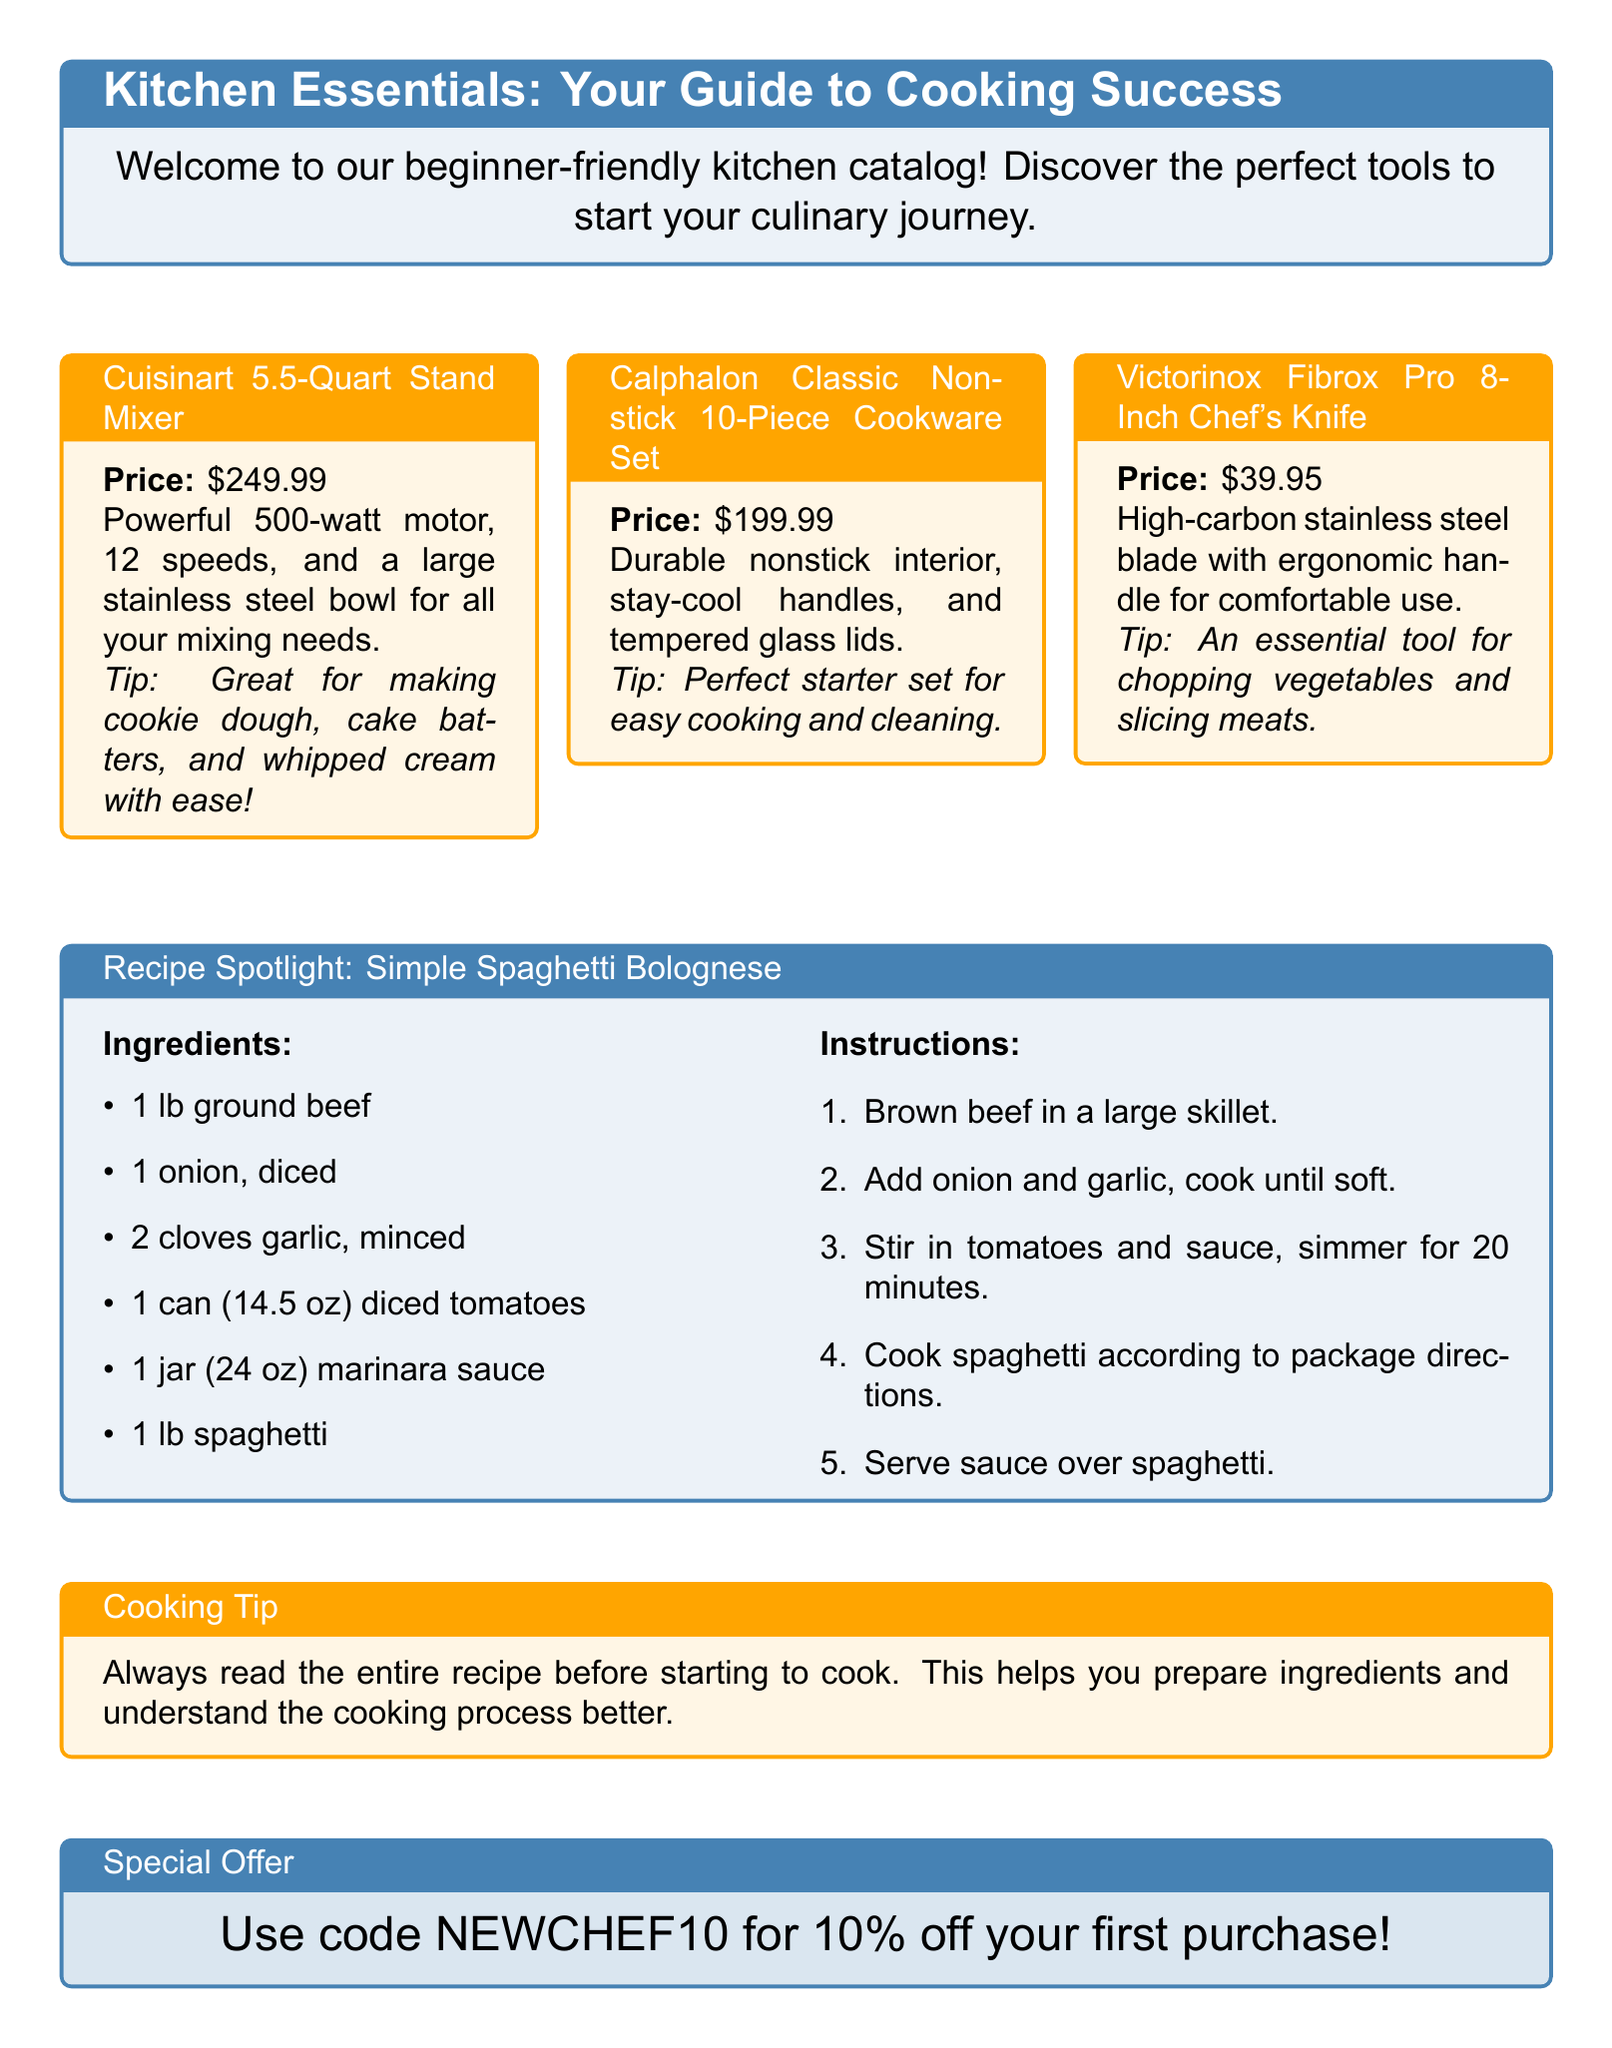what is the price of the Cuisinart Stand Mixer? The price of the Cuisinart 5.5-Quart Stand Mixer is listed in the document.
Answer: $249.99 how many pieces are in the Calphalon Cookware Set? The Calphalon Classic Nonstick Cookware Set details how many pieces it contains.
Answer: 10-Piece what type of blade does the Victorinox Chef's Knife have? The Victorinox Fibrox Pro 8-Inch Chef's Knife description states the type of blade material.
Answer: High-carbon stainless steel what is the first ingredient in the spaghetti bolognese recipe? The recipe spotlight lists the ingredients in order, and the first one is noted in the list.
Answer: Ground beef how long should you simmer the sauce in the spaghetti bolognese recipe? The instructions in the recipe specify the duration for this particular step.
Answer: 20 minutes what is a cooking tip mentioned in the document? The cooking tip provided suggests an important preparation step for cooking.
Answer: Read the entire recipe what discount code is offered in the special offer? The special offer section includes a code for first-time buyers.
Answer: NEWCHEF10 what is the purpose of the kitchen catalog? The introduction of the document explains the catalog's purpose for new cooks.
Answer: Help beginners in cooking 